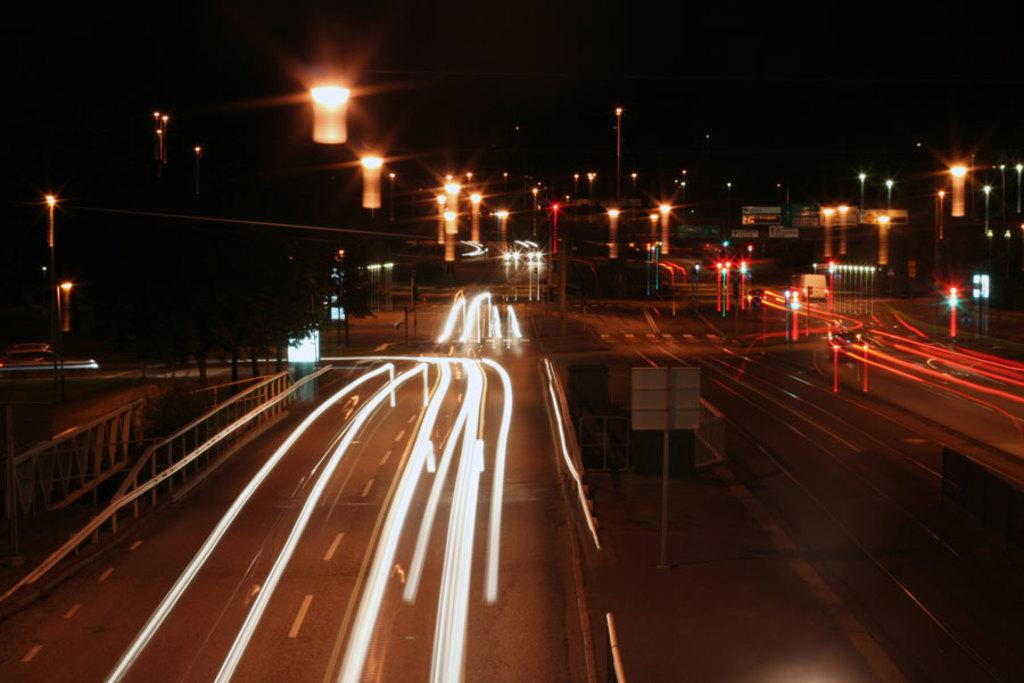What is the time of day depicted in the image? The image shows a night view of the roads. What can be seen on the roads in the image? There are lights on the roads. What type of lights are present in the background of the image? There are street lights with poles in the background. How would you describe the color of the sky in the image? The sky in the background is dark. What type of afterthought is being expressed by the hammer in the image? There is no hammer present in the image. How is the waste being managed in the image? There is no mention of waste management in the image. 